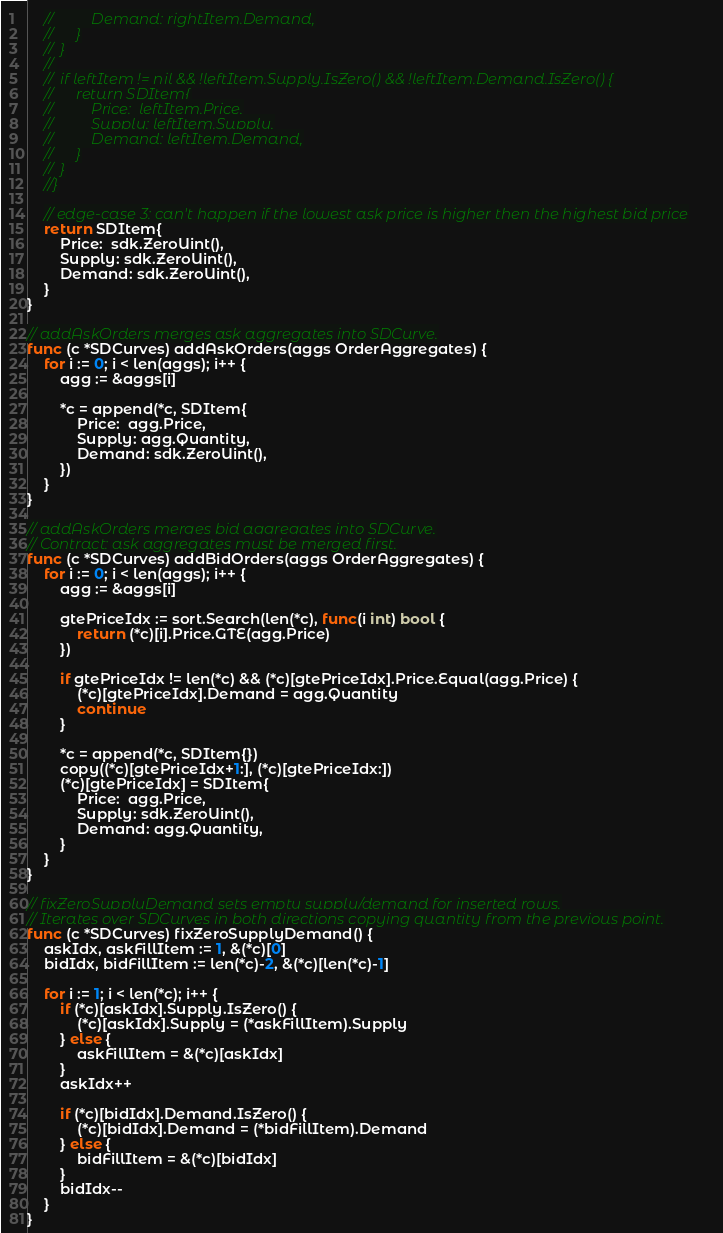<code> <loc_0><loc_0><loc_500><loc_500><_Go_>	//			Demand: rightItem.Demand,
	//		}
	//	}
	//
	//	if leftItem != nil && !leftItem.Supply.IsZero() && !leftItem.Demand.IsZero() {
	//		return SDItem{
	//			Price:  leftItem.Price,
	//			Supply: leftItem.Supply,
	//			Demand: leftItem.Demand,
	//		}
	//	}
	//}

	// edge-case 3: can't happen if the lowest ask price is higher then the highest bid price
	return SDItem{
		Price:  sdk.ZeroUint(),
		Supply: sdk.ZeroUint(),
		Demand: sdk.ZeroUint(),
	}
}

// addAskOrders merges ask aggregates into SDCurve.
func (c *SDCurves) addAskOrders(aggs OrderAggregates) {
	for i := 0; i < len(aggs); i++ {
		agg := &aggs[i]

		*c = append(*c, SDItem{
			Price:  agg.Price,
			Supply: agg.Quantity,
			Demand: sdk.ZeroUint(),
		})
	}
}

// addAskOrders merges bid aggregates into SDCurve.
// Contract: ask aggregates must be merged first.
func (c *SDCurves) addBidOrders(aggs OrderAggregates) {
	for i := 0; i < len(aggs); i++ {
		agg := &aggs[i]

		gtePriceIdx := sort.Search(len(*c), func(i int) bool {
			return (*c)[i].Price.GTE(agg.Price)
		})

		if gtePriceIdx != len(*c) && (*c)[gtePriceIdx].Price.Equal(agg.Price) {
			(*c)[gtePriceIdx].Demand = agg.Quantity
			continue
		}

		*c = append(*c, SDItem{})
		copy((*c)[gtePriceIdx+1:], (*c)[gtePriceIdx:])
		(*c)[gtePriceIdx] = SDItem{
			Price:  agg.Price,
			Supply: sdk.ZeroUint(),
			Demand: agg.Quantity,
		}
	}
}

// fixZeroSupplyDemand sets empty supply/demand for inserted rows.
// Iterates over SDCurves in both directions copying quantity from the previous point.
func (c *SDCurves) fixZeroSupplyDemand() {
	askIdx, askFillItem := 1, &(*c)[0]
	bidIdx, bidFillItem := len(*c)-2, &(*c)[len(*c)-1]

	for i := 1; i < len(*c); i++ {
		if (*c)[askIdx].Supply.IsZero() {
			(*c)[askIdx].Supply = (*askFillItem).Supply
		} else {
			askFillItem = &(*c)[askIdx]
		}
		askIdx++

		if (*c)[bidIdx].Demand.IsZero() {
			(*c)[bidIdx].Demand = (*bidFillItem).Demand
		} else {
			bidFillItem = &(*c)[bidIdx]
		}
		bidIdx--
	}
}
</code> 